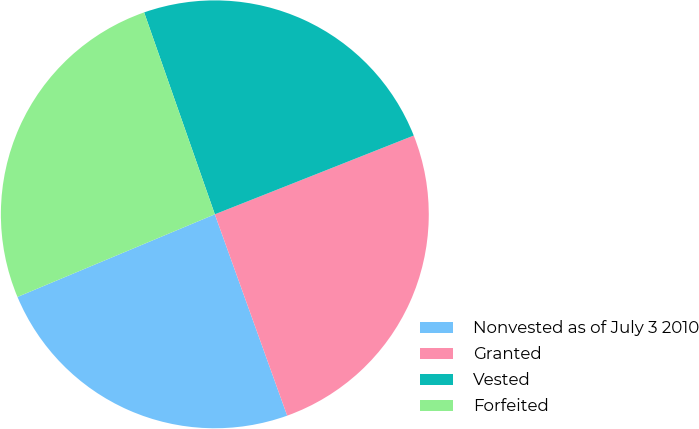<chart> <loc_0><loc_0><loc_500><loc_500><pie_chart><fcel>Nonvested as of July 3 2010<fcel>Granted<fcel>Vested<fcel>Forfeited<nl><fcel>24.18%<fcel>25.51%<fcel>24.36%<fcel>25.95%<nl></chart> 